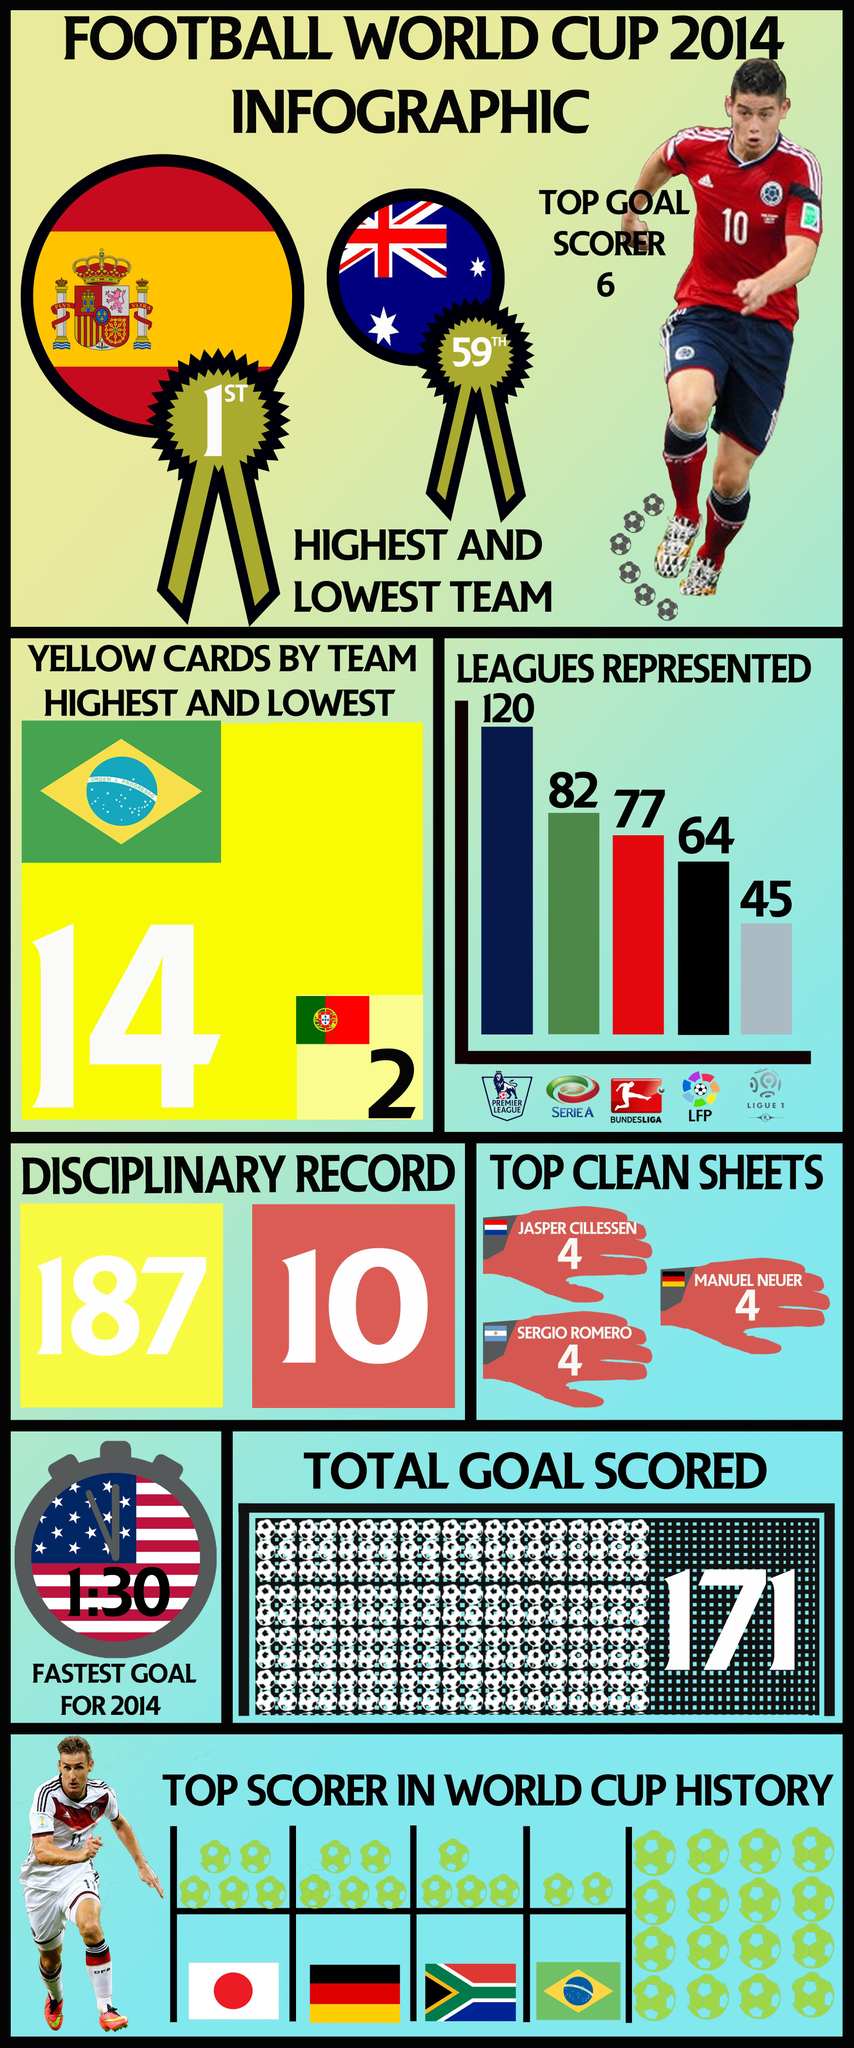Give some essential details in this illustration. The Bundesliga is the league that is represented by the color red on the bar chart. 